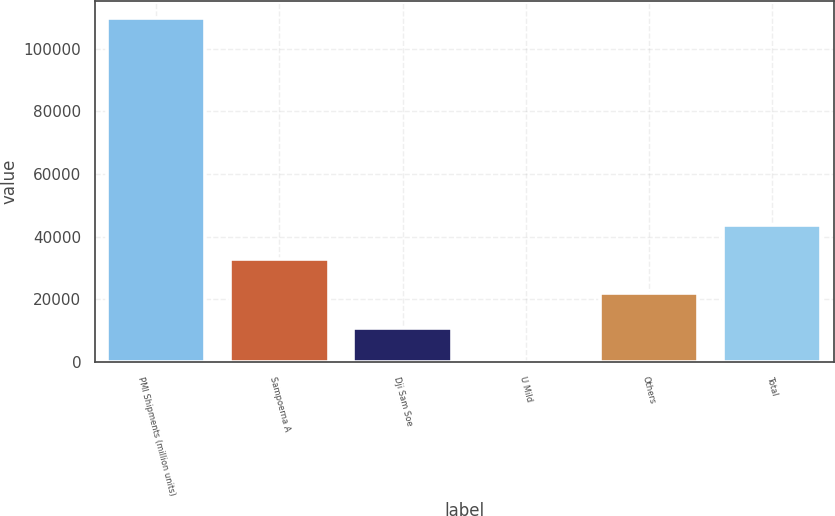Convert chart. <chart><loc_0><loc_0><loc_500><loc_500><bar_chart><fcel>PMI Shipments (million units)<fcel>Sampoerna A<fcel>Dji Sam Soe<fcel>U Mild<fcel>Others<fcel>Total<nl><fcel>109694<fcel>32912<fcel>10974.3<fcel>5.4<fcel>21943.1<fcel>43880.8<nl></chart> 